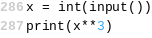Convert code to text. <code><loc_0><loc_0><loc_500><loc_500><_Python_>x = int(input())
print(x**3)
</code> 